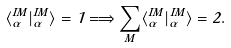<formula> <loc_0><loc_0><loc_500><loc_500>\langle \Phi _ { \alpha } ^ { I M } | \Phi _ { \alpha } ^ { I M } \rangle = 1 \Longrightarrow \sum _ { M } \langle \Phi _ { \alpha } ^ { I M } | \Phi _ { \alpha } ^ { I M } \rangle = 2 .</formula> 